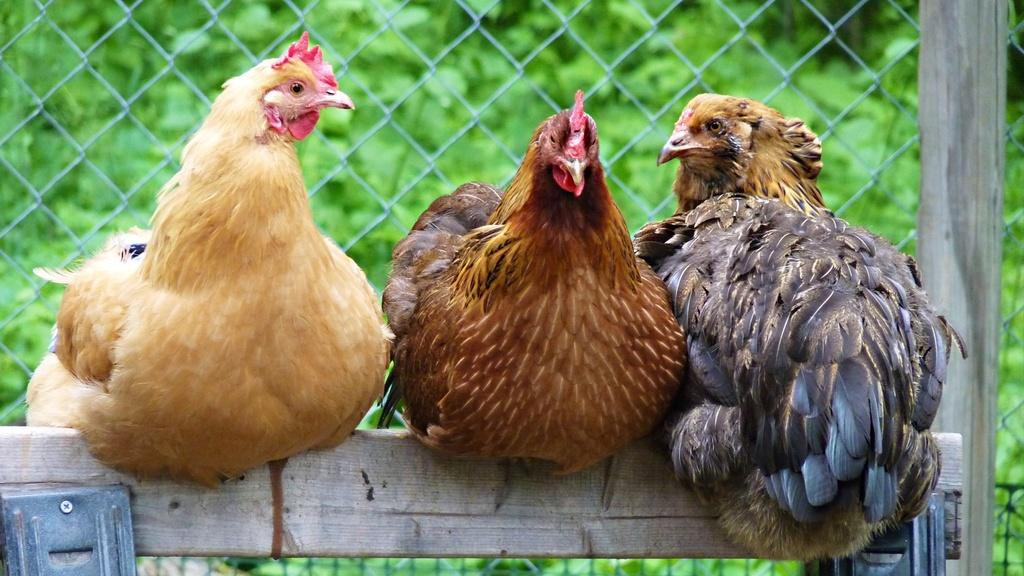How many hens are in the image? There are three hens in the image. What are the hens standing on? The hens are on a wooden object. What can be seen in the background of the image? There is a mesh and greenery visible in the background of the image. What is on the right side of the image? There is a wooden pole on the right side of the image. What type of cough medicine is the hen holding in the image? There is no cough medicine present in the image; it features three hens on a wooden object. How many rings can be seen on the hens' legs in the image? There are no rings visible on the hens' legs in the image. 